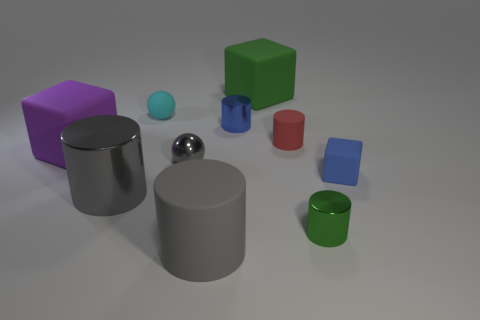There is a big matte object that is the same color as the large shiny thing; what shape is it?
Keep it short and to the point. Cylinder. There is a tiny metal thing that is right of the green block; does it have the same color as the large thing that is on the left side of the big metallic object?
Offer a terse response. No. What is the size of the shiny cylinder that is the same color as the big matte cylinder?
Offer a terse response. Large. Is there a big yellow sphere that has the same material as the tiny gray thing?
Keep it short and to the point. No. The tiny matte cube has what color?
Your answer should be very brief. Blue. There is a cyan rubber thing that is behind the large matte object in front of the big matte block that is in front of the big green matte block; how big is it?
Provide a succinct answer. Small. What number of other things are the same shape as the tiny green shiny object?
Provide a short and direct response. 4. The large object that is on the left side of the gray ball and behind the gray metallic sphere is what color?
Your answer should be very brief. Purple. Is there any other thing that is the same size as the gray shiny ball?
Your answer should be very brief. Yes. There is a tiny sphere that is to the right of the cyan rubber object; is it the same color as the small rubber cube?
Give a very brief answer. No. 